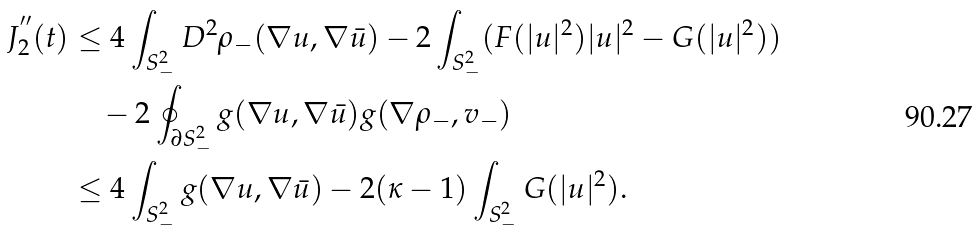<formula> <loc_0><loc_0><loc_500><loc_500>J ^ { ^ { \prime \prime } } _ { 2 } ( t ) & \leq 4 \int _ { S ^ { 2 } _ { - } } D ^ { 2 } \rho _ { - } ( \nabla u , \nabla \bar { u } ) - 2 \int _ { S ^ { 2 } _ { - } } ( F ( | u | ^ { 2 } ) | u | ^ { 2 } - G ( | u | ^ { 2 } ) ) \\ & \quad - 2 \oint _ { \partial S ^ { 2 } _ { - } } g ( \nabla u , \nabla \bar { u } ) g ( \nabla \rho _ { - } , { v } _ { - } ) \\ & \leq 4 \int _ { S ^ { 2 } _ { - } } g ( \nabla u , \nabla \bar { u } ) - 2 ( \kappa - 1 ) \int _ { S ^ { 2 } _ { - } } G ( | u | ^ { 2 } ) .</formula> 